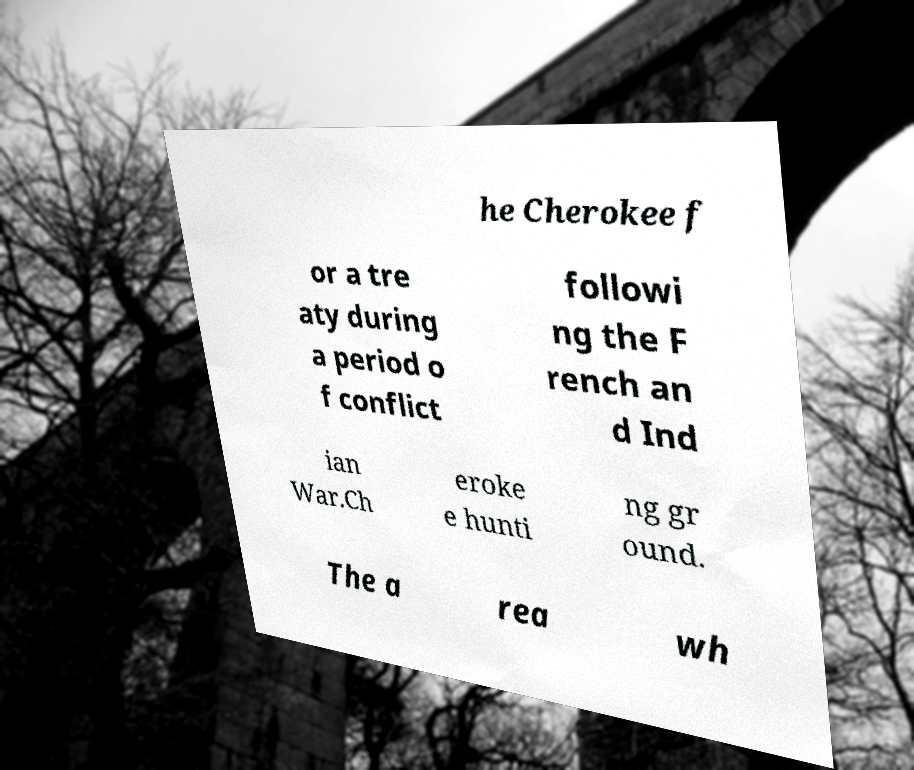There's text embedded in this image that I need extracted. Can you transcribe it verbatim? he Cherokee f or a tre aty during a period o f conflict followi ng the F rench an d Ind ian War.Ch eroke e hunti ng gr ound. The a rea wh 